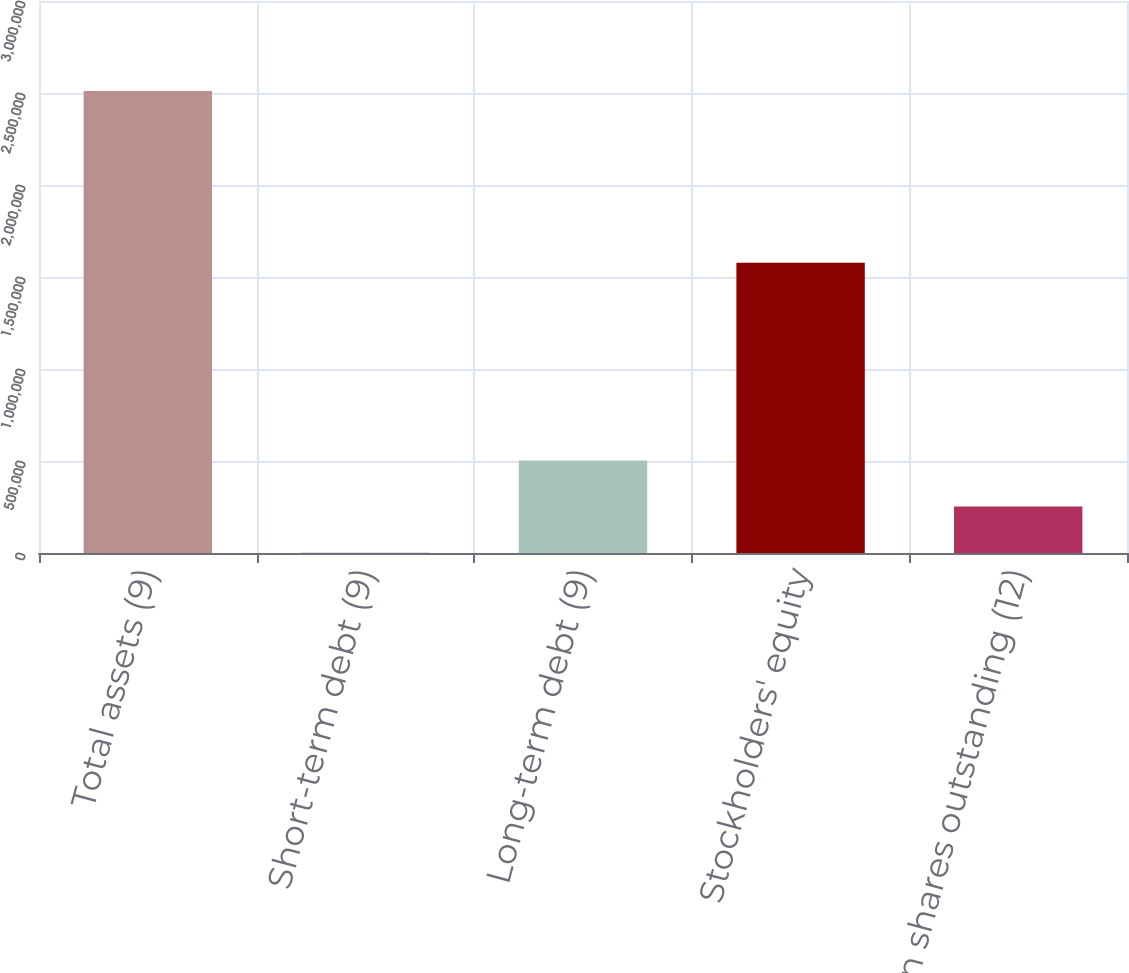<chart> <loc_0><loc_0><loc_500><loc_500><bar_chart><fcel>Total assets (9)<fcel>Short-term debt (9)<fcel>Long-term debt (9)<fcel>Stockholders' equity<fcel>Common shares outstanding (12)<nl><fcel>2.51032e+06<fcel>1153<fcel>502987<fcel>1.57773e+06<fcel>252070<nl></chart> 